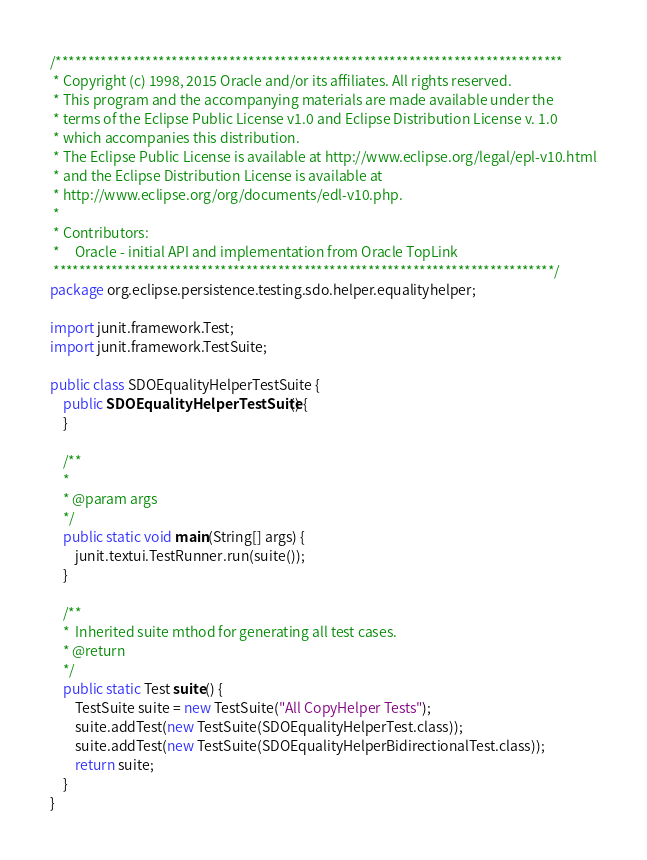Convert code to text. <code><loc_0><loc_0><loc_500><loc_500><_Java_>/*******************************************************************************
 * Copyright (c) 1998, 2015 Oracle and/or its affiliates. All rights reserved.
 * This program and the accompanying materials are made available under the
 * terms of the Eclipse Public License v1.0 and Eclipse Distribution License v. 1.0
 * which accompanies this distribution.
 * The Eclipse Public License is available at http://www.eclipse.org/legal/epl-v10.html
 * and the Eclipse Distribution License is available at
 * http://www.eclipse.org/org/documents/edl-v10.php.
 *
 * Contributors:
 *     Oracle - initial API and implementation from Oracle TopLink
 ******************************************************************************/
package org.eclipse.persistence.testing.sdo.helper.equalityhelper;

import junit.framework.Test;
import junit.framework.TestSuite;

public class SDOEqualityHelperTestSuite {
    public SDOEqualityHelperTestSuite() {
    }

    /**
    *
    * @param args
    */
    public static void main(String[] args) {
        junit.textui.TestRunner.run(suite());
    }

    /**
    *  Inherited suite mthod for generating all test cases.
    * @return
    */
    public static Test suite() {
        TestSuite suite = new TestSuite("All CopyHelper Tests");
        suite.addTest(new TestSuite(SDOEqualityHelperTest.class));
        suite.addTest(new TestSuite(SDOEqualityHelperBidirectionalTest.class));
        return suite;
    }
}
</code> 